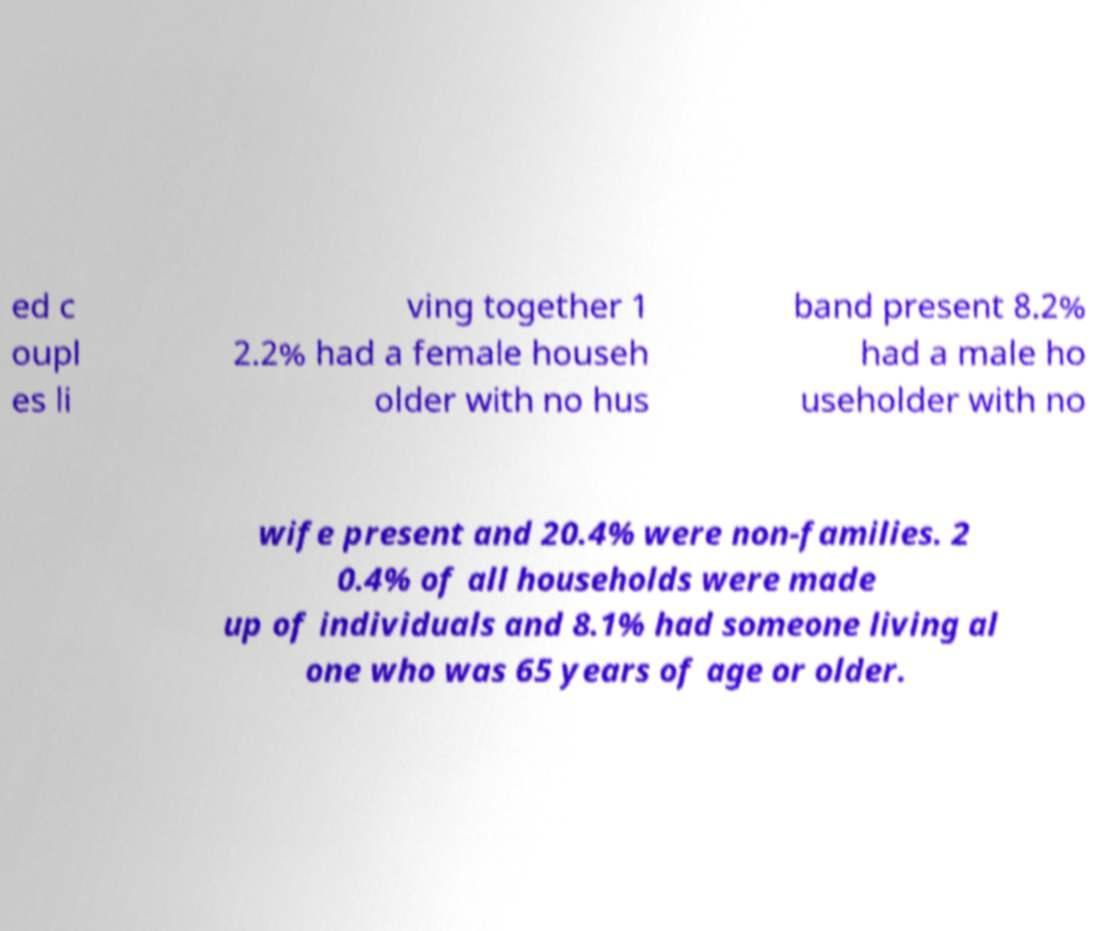Could you assist in decoding the text presented in this image and type it out clearly? ed c oupl es li ving together 1 2.2% had a female househ older with no hus band present 8.2% had a male ho useholder with no wife present and 20.4% were non-families. 2 0.4% of all households were made up of individuals and 8.1% had someone living al one who was 65 years of age or older. 